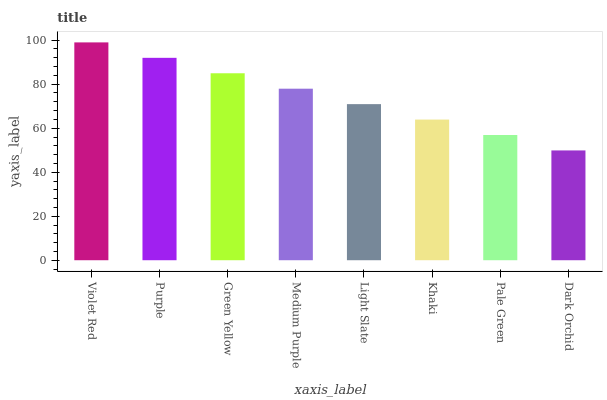Is Dark Orchid the minimum?
Answer yes or no. Yes. Is Violet Red the maximum?
Answer yes or no. Yes. Is Purple the minimum?
Answer yes or no. No. Is Purple the maximum?
Answer yes or no. No. Is Violet Red greater than Purple?
Answer yes or no. Yes. Is Purple less than Violet Red?
Answer yes or no. Yes. Is Purple greater than Violet Red?
Answer yes or no. No. Is Violet Red less than Purple?
Answer yes or no. No. Is Medium Purple the high median?
Answer yes or no. Yes. Is Light Slate the low median?
Answer yes or no. Yes. Is Violet Red the high median?
Answer yes or no. No. Is Green Yellow the low median?
Answer yes or no. No. 